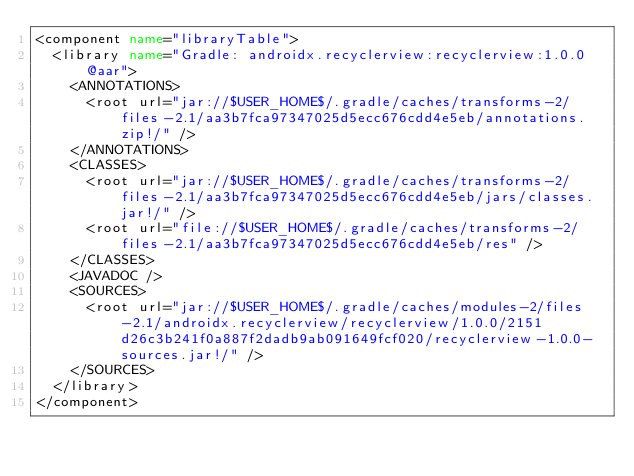<code> <loc_0><loc_0><loc_500><loc_500><_XML_><component name="libraryTable">
  <library name="Gradle: androidx.recyclerview:recyclerview:1.0.0@aar">
    <ANNOTATIONS>
      <root url="jar://$USER_HOME$/.gradle/caches/transforms-2/files-2.1/aa3b7fca97347025d5ecc676cdd4e5eb/annotations.zip!/" />
    </ANNOTATIONS>
    <CLASSES>
      <root url="jar://$USER_HOME$/.gradle/caches/transforms-2/files-2.1/aa3b7fca97347025d5ecc676cdd4e5eb/jars/classes.jar!/" />
      <root url="file://$USER_HOME$/.gradle/caches/transforms-2/files-2.1/aa3b7fca97347025d5ecc676cdd4e5eb/res" />
    </CLASSES>
    <JAVADOC />
    <SOURCES>
      <root url="jar://$USER_HOME$/.gradle/caches/modules-2/files-2.1/androidx.recyclerview/recyclerview/1.0.0/2151d26c3b241f0a887f2dadb9ab091649fcf020/recyclerview-1.0.0-sources.jar!/" />
    </SOURCES>
  </library>
</component></code> 